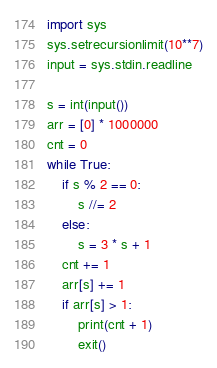<code> <loc_0><loc_0><loc_500><loc_500><_Python_>import sys
sys.setrecursionlimit(10**7)
input = sys.stdin.readline

s = int(input())
arr = [0] * 1000000
cnt = 0
while True:
    if s % 2 == 0:
        s //= 2
    else:
        s = 3 * s + 1
    cnt += 1
    arr[s] += 1
    if arr[s] > 1:
        print(cnt + 1)
        exit()
</code> 